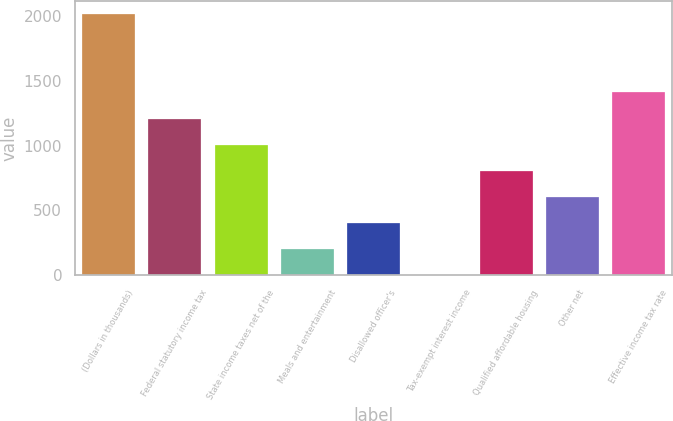Convert chart. <chart><loc_0><loc_0><loc_500><loc_500><bar_chart><fcel>(Dollars in thousands)<fcel>Federal statutory income tax<fcel>State income taxes net of the<fcel>Meals and entertainment<fcel>Disallowed officer's<fcel>Tax-exempt interest income<fcel>Qualified affordable housing<fcel>Other net<fcel>Effective income tax rate<nl><fcel>2015<fcel>1209.08<fcel>1007.6<fcel>201.68<fcel>403.16<fcel>0.2<fcel>806.12<fcel>604.64<fcel>1410.56<nl></chart> 